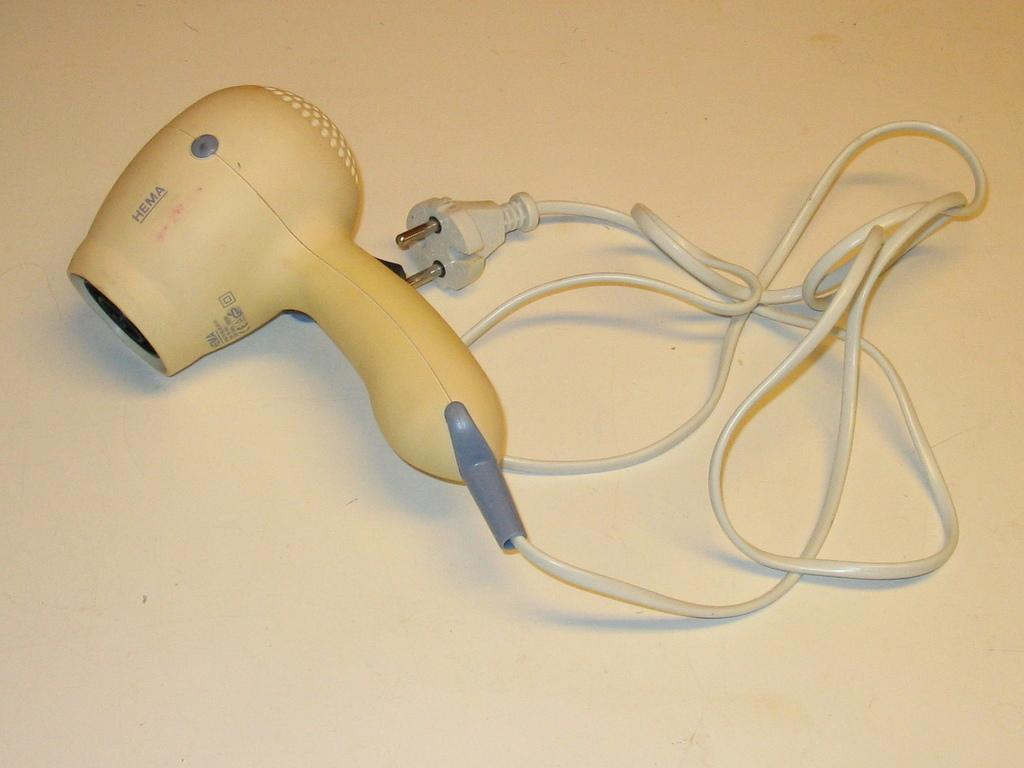What is the main object in the image? There is a hair dryer in the image. What else can be seen in the image besides the hair dryer? Cable wires are present in the image. What is the color of the surface in the image? The surface in the image is white. What type of education does the father in the image have? There is no father present in the image, and therefore no information about his education can be provided. 